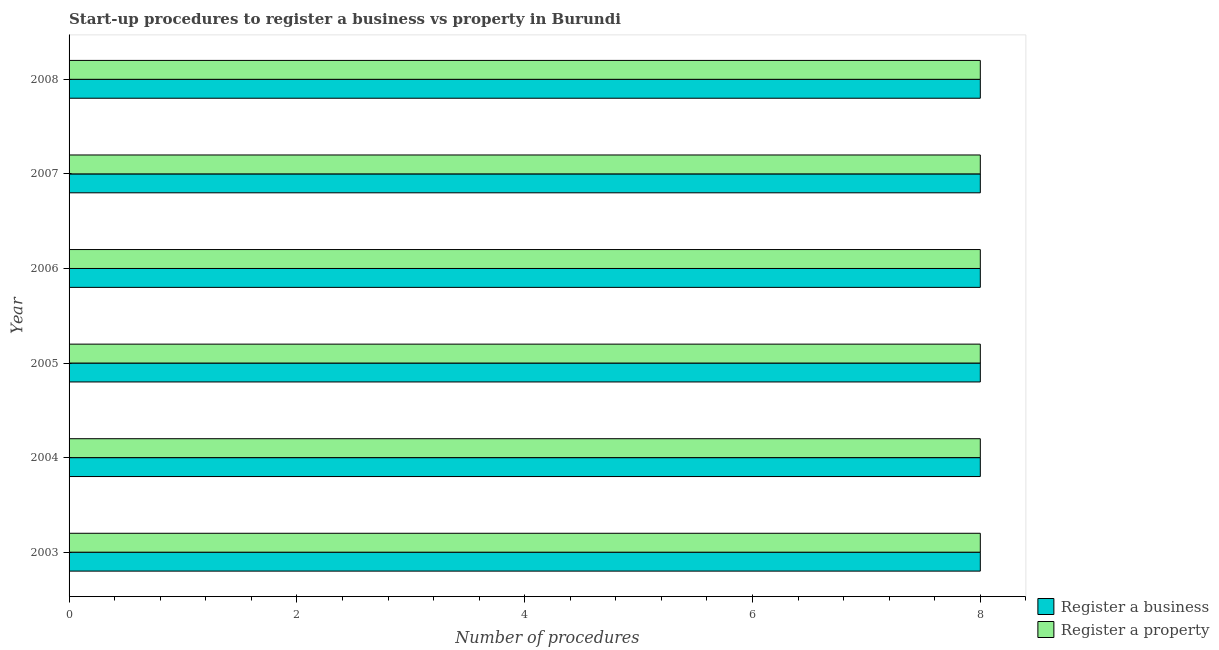How many different coloured bars are there?
Provide a succinct answer. 2. How many groups of bars are there?
Your response must be concise. 6. Are the number of bars on each tick of the Y-axis equal?
Provide a short and direct response. Yes. How many bars are there on the 1st tick from the bottom?
Make the answer very short. 2. What is the label of the 1st group of bars from the top?
Offer a terse response. 2008. In how many cases, is the number of bars for a given year not equal to the number of legend labels?
Your response must be concise. 0. What is the number of procedures to register a business in 2005?
Your response must be concise. 8. Across all years, what is the maximum number of procedures to register a property?
Make the answer very short. 8. Across all years, what is the minimum number of procedures to register a property?
Provide a short and direct response. 8. In which year was the number of procedures to register a business maximum?
Your answer should be compact. 2003. What is the total number of procedures to register a property in the graph?
Provide a succinct answer. 48. What is the average number of procedures to register a property per year?
Make the answer very short. 8. In the year 2004, what is the difference between the number of procedures to register a business and number of procedures to register a property?
Give a very brief answer. 0. Is the difference between the number of procedures to register a property in 2004 and 2007 greater than the difference between the number of procedures to register a business in 2004 and 2007?
Provide a short and direct response. No. Is the sum of the number of procedures to register a property in 2003 and 2005 greater than the maximum number of procedures to register a business across all years?
Give a very brief answer. Yes. What does the 2nd bar from the top in 2005 represents?
Offer a very short reply. Register a business. What does the 1st bar from the bottom in 2008 represents?
Make the answer very short. Register a business. Are all the bars in the graph horizontal?
Give a very brief answer. Yes. How many years are there in the graph?
Your answer should be compact. 6. Where does the legend appear in the graph?
Keep it short and to the point. Bottom right. How many legend labels are there?
Make the answer very short. 2. How are the legend labels stacked?
Your response must be concise. Vertical. What is the title of the graph?
Offer a terse response. Start-up procedures to register a business vs property in Burundi. Does "Infant" appear as one of the legend labels in the graph?
Offer a very short reply. No. What is the label or title of the X-axis?
Provide a succinct answer. Number of procedures. What is the label or title of the Y-axis?
Offer a terse response. Year. What is the Number of procedures in Register a business in 2003?
Provide a succinct answer. 8. What is the Number of procedures in Register a property in 2003?
Offer a very short reply. 8. What is the Number of procedures in Register a business in 2005?
Your answer should be very brief. 8. What is the Number of procedures of Register a property in 2006?
Offer a very short reply. 8. What is the Number of procedures in Register a business in 2008?
Your answer should be very brief. 8. What is the Number of procedures of Register a property in 2008?
Keep it short and to the point. 8. Across all years, what is the maximum Number of procedures of Register a business?
Ensure brevity in your answer.  8. What is the total Number of procedures of Register a property in the graph?
Offer a terse response. 48. What is the difference between the Number of procedures in Register a business in 2003 and that in 2004?
Give a very brief answer. 0. What is the difference between the Number of procedures in Register a property in 2003 and that in 2005?
Provide a succinct answer. 0. What is the difference between the Number of procedures in Register a business in 2003 and that in 2007?
Make the answer very short. 0. What is the difference between the Number of procedures in Register a property in 2003 and that in 2007?
Provide a succinct answer. 0. What is the difference between the Number of procedures of Register a business in 2003 and that in 2008?
Your answer should be compact. 0. What is the difference between the Number of procedures in Register a business in 2004 and that in 2006?
Your response must be concise. 0. What is the difference between the Number of procedures in Register a property in 2004 and that in 2007?
Make the answer very short. 0. What is the difference between the Number of procedures in Register a business in 2004 and that in 2008?
Provide a short and direct response. 0. What is the difference between the Number of procedures of Register a business in 2005 and that in 2006?
Provide a succinct answer. 0. What is the difference between the Number of procedures of Register a property in 2005 and that in 2006?
Your answer should be very brief. 0. What is the difference between the Number of procedures of Register a property in 2005 and that in 2007?
Your answer should be very brief. 0. What is the difference between the Number of procedures of Register a property in 2005 and that in 2008?
Offer a terse response. 0. What is the difference between the Number of procedures of Register a business in 2003 and the Number of procedures of Register a property in 2004?
Offer a very short reply. 0. What is the difference between the Number of procedures in Register a business in 2003 and the Number of procedures in Register a property in 2005?
Ensure brevity in your answer.  0. What is the difference between the Number of procedures of Register a business in 2003 and the Number of procedures of Register a property in 2007?
Your response must be concise. 0. What is the difference between the Number of procedures in Register a business in 2003 and the Number of procedures in Register a property in 2008?
Provide a succinct answer. 0. What is the difference between the Number of procedures in Register a business in 2004 and the Number of procedures in Register a property in 2005?
Provide a short and direct response. 0. What is the difference between the Number of procedures of Register a business in 2004 and the Number of procedures of Register a property in 2008?
Provide a short and direct response. 0. What is the difference between the Number of procedures in Register a business in 2005 and the Number of procedures in Register a property in 2006?
Provide a short and direct response. 0. What is the difference between the Number of procedures of Register a business in 2005 and the Number of procedures of Register a property in 2007?
Provide a succinct answer. 0. What is the difference between the Number of procedures in Register a business in 2006 and the Number of procedures in Register a property in 2008?
Provide a short and direct response. 0. What is the average Number of procedures of Register a business per year?
Ensure brevity in your answer.  8. In the year 2006, what is the difference between the Number of procedures of Register a business and Number of procedures of Register a property?
Give a very brief answer. 0. In the year 2007, what is the difference between the Number of procedures in Register a business and Number of procedures in Register a property?
Your answer should be compact. 0. In the year 2008, what is the difference between the Number of procedures of Register a business and Number of procedures of Register a property?
Keep it short and to the point. 0. What is the ratio of the Number of procedures of Register a business in 2003 to that in 2004?
Keep it short and to the point. 1. What is the ratio of the Number of procedures in Register a property in 2003 to that in 2004?
Give a very brief answer. 1. What is the ratio of the Number of procedures of Register a property in 2003 to that in 2005?
Provide a short and direct response. 1. What is the ratio of the Number of procedures of Register a property in 2003 to that in 2006?
Your answer should be very brief. 1. What is the ratio of the Number of procedures in Register a business in 2003 to that in 2007?
Offer a terse response. 1. What is the ratio of the Number of procedures in Register a property in 2003 to that in 2007?
Provide a short and direct response. 1. What is the ratio of the Number of procedures of Register a business in 2003 to that in 2008?
Keep it short and to the point. 1. What is the ratio of the Number of procedures in Register a property in 2003 to that in 2008?
Keep it short and to the point. 1. What is the ratio of the Number of procedures of Register a business in 2004 to that in 2006?
Offer a terse response. 1. What is the ratio of the Number of procedures in Register a property in 2004 to that in 2007?
Offer a very short reply. 1. What is the ratio of the Number of procedures in Register a property in 2004 to that in 2008?
Your response must be concise. 1. What is the ratio of the Number of procedures in Register a business in 2005 to that in 2006?
Offer a very short reply. 1. What is the ratio of the Number of procedures of Register a business in 2005 to that in 2007?
Your answer should be compact. 1. What is the ratio of the Number of procedures in Register a property in 2006 to that in 2007?
Keep it short and to the point. 1. What is the ratio of the Number of procedures in Register a property in 2006 to that in 2008?
Provide a succinct answer. 1. What is the ratio of the Number of procedures of Register a property in 2007 to that in 2008?
Offer a terse response. 1. What is the difference between the highest and the second highest Number of procedures of Register a property?
Your response must be concise. 0. What is the difference between the highest and the lowest Number of procedures in Register a business?
Ensure brevity in your answer.  0. 